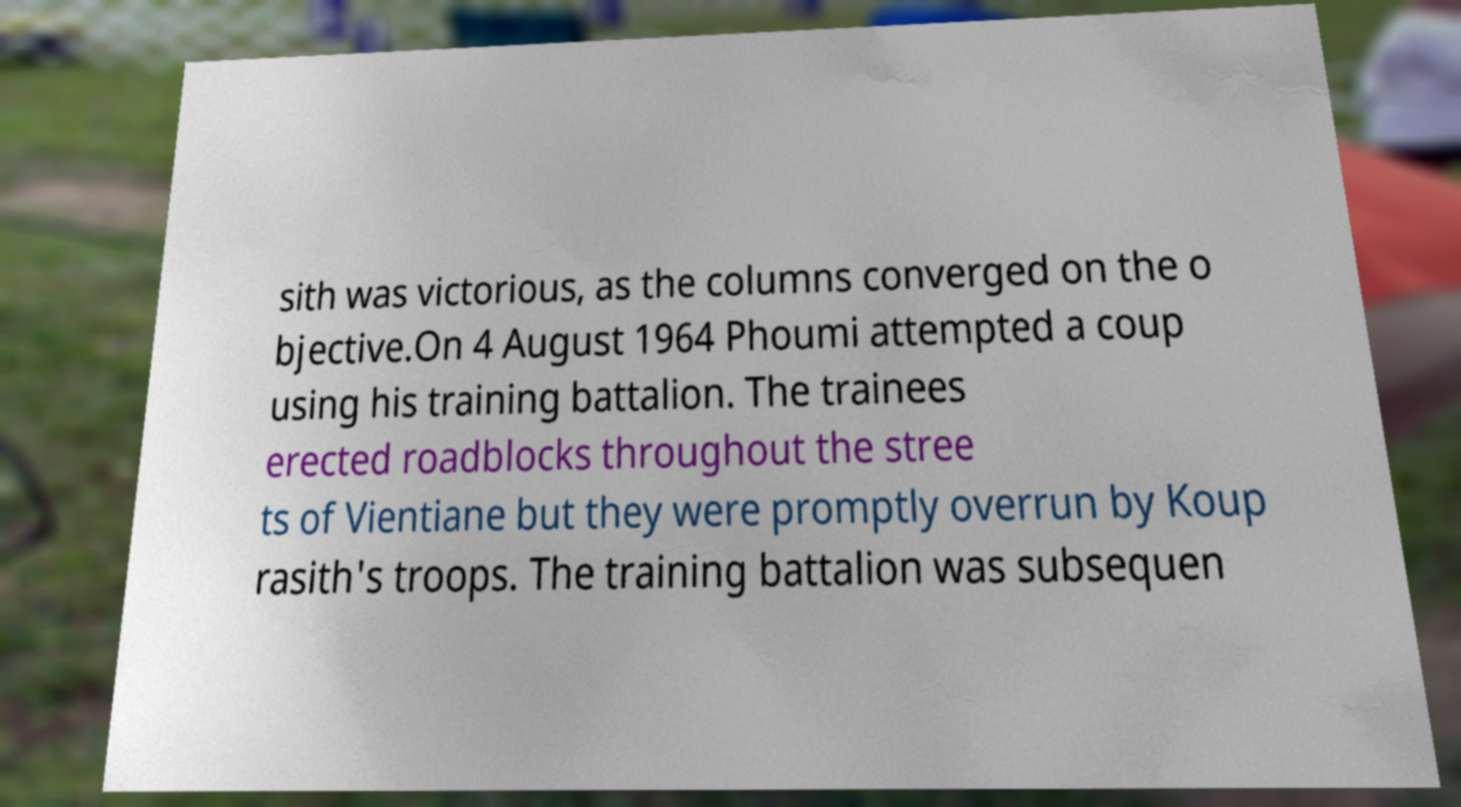Can you accurately transcribe the text from the provided image for me? sith was victorious, as the columns converged on the o bjective.On 4 August 1964 Phoumi attempted a coup using his training battalion. The trainees erected roadblocks throughout the stree ts of Vientiane but they were promptly overrun by Koup rasith's troops. The training battalion was subsequen 